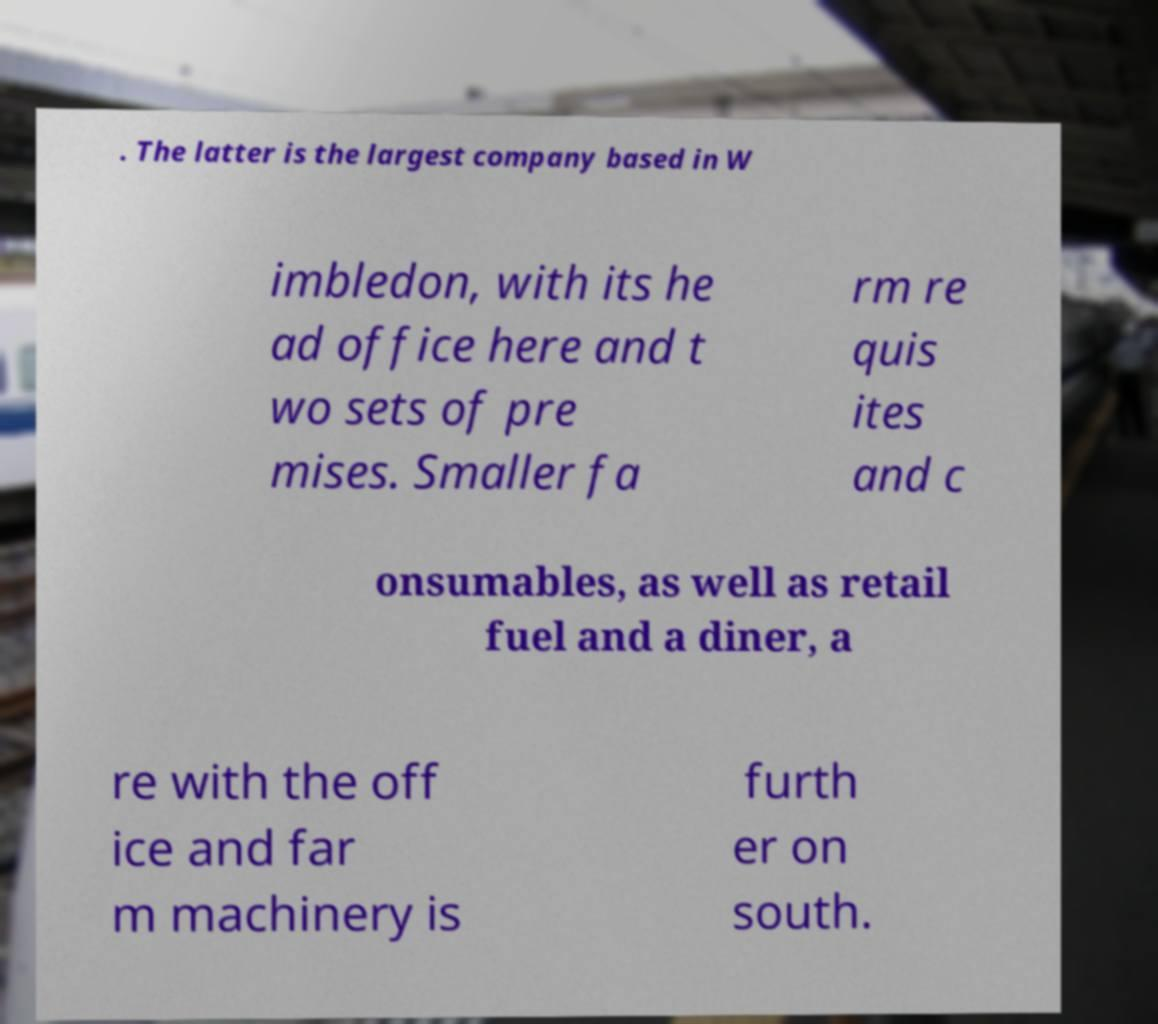Please identify and transcribe the text found in this image. . The latter is the largest company based in W imbledon, with its he ad office here and t wo sets of pre mises. Smaller fa rm re quis ites and c onsumables, as well as retail fuel and a diner, a re with the off ice and far m machinery is furth er on south. 